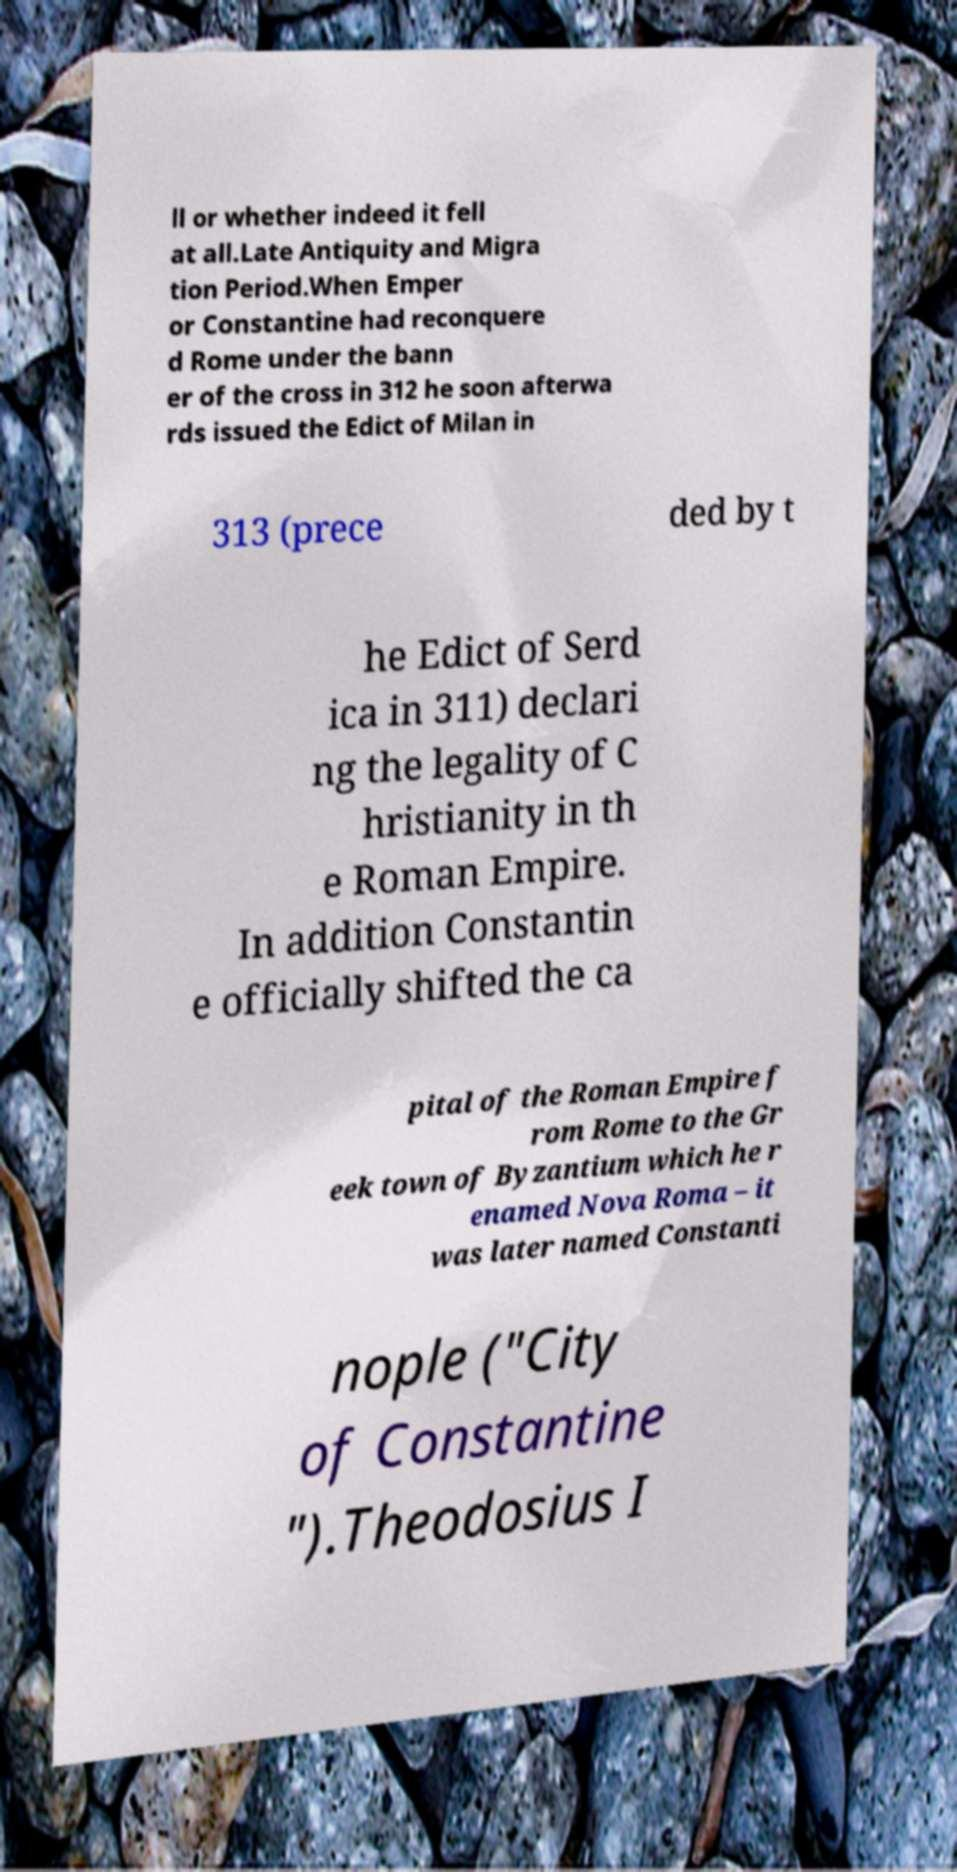Could you extract and type out the text from this image? ll or whether indeed it fell at all.Late Antiquity and Migra tion Period.When Emper or Constantine had reconquere d Rome under the bann er of the cross in 312 he soon afterwa rds issued the Edict of Milan in 313 (prece ded by t he Edict of Serd ica in 311) declari ng the legality of C hristianity in th e Roman Empire. In addition Constantin e officially shifted the ca pital of the Roman Empire f rom Rome to the Gr eek town of Byzantium which he r enamed Nova Roma – it was later named Constanti nople ("City of Constantine ").Theodosius I 